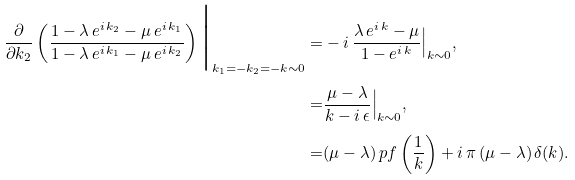<formula> <loc_0><loc_0><loc_500><loc_500>\frac { \partial } { \partial k _ { 2 } } \left ( \frac { 1 - \lambda \, e ^ { i \, k _ { 2 } } - \mu \, e ^ { i \, k _ { 1 } } } { 1 - \lambda \, e ^ { i \, k _ { 1 } } - \mu \, e ^ { i \, k _ { 2 } } } \right ) \Big | _ { k _ { 1 } = - k _ { 2 } = - k \sim 0 } = & - i \, \frac { \lambda \, e ^ { i \, k } - \mu } { 1 - e ^ { i \, k } } \Big | _ { k \sim 0 } , \\ = & \frac { \mu - \lambda } { k - i \, \epsilon } \Big | _ { k \sim 0 } , \\ = & ( \mu - \lambda ) \, p f \left ( \frac { 1 } { k } \right ) + i \, \pi \, ( \mu - \lambda ) \, \delta ( k ) .</formula> 